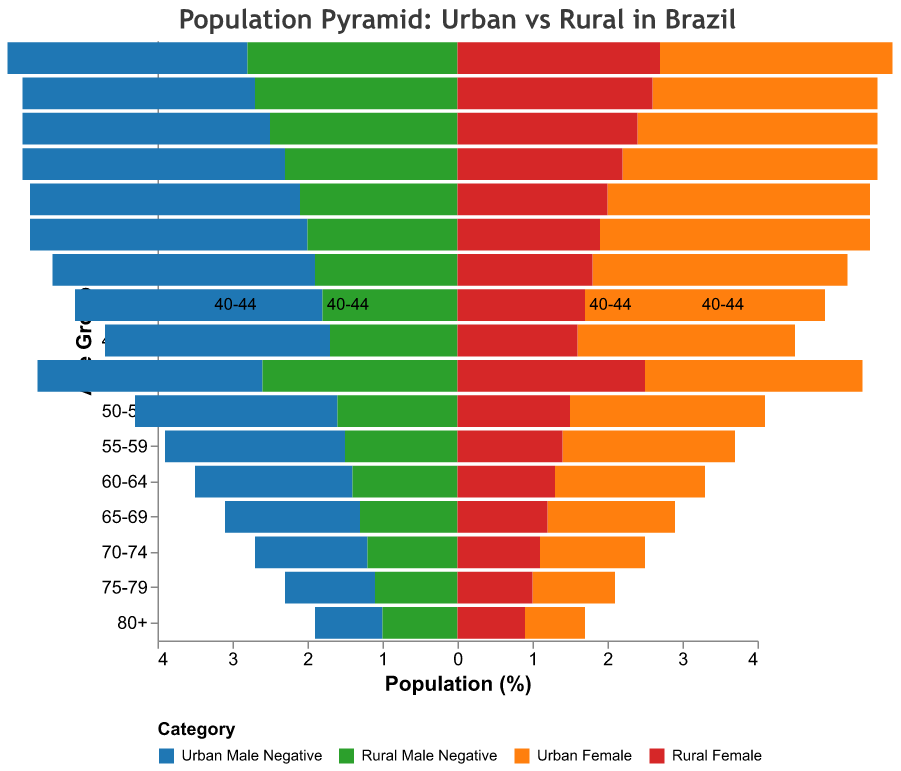What is the title of the figure? The title is usually displayed at the top of the figure. In this case, the title is "Population Pyramid: Urban vs Rural in Brazil".
Answer: Population Pyramid: Urban vs Rural in Brazil Which age group has the highest percentage of urban males? To find the age group with the highest percentage of urban males, look for the category "Urban Male" and identify the age group with the largest bar. The largest value in the "Urban Male" category is 3.7 for the age group "30-34".
Answer: 30-34 In the 80+ age group, which gender has a higher percentage in rural areas? For the age group "80+", compare the bars for "Rural Male" and "Rural Female". "Rural Male" has a value of 1.0, and "Rural Female" has a value of 0.9.
Answer: Rural Male How does the percentage of urban females in the age group 25-29 compare to that of rural females in the same age group? Identify the bars for the age group "25-29" for both "Urban Female" and "Rural Female". "Urban Female" is 3.5, and "Rural Female" is 2.0.
Answer: Urban Female has a higher percentage than Rural Female What is the difference in percentage between urban males and rural males in the age group 20-24? For the age group "20-24", identify "Urban Male" and "Rural Male" percentages. "Urban Male" is 3.5, and "Rural Male" is 2.3. Calculate the difference: 3.5 - 2.3 = 1.2.
Answer: 1.2 Which age group has approximately equal percentages of urban and rural populations for both males and females? Look for age groups where the bars for "Urban Male", "Urban Female", "Rural Male", and "Rural Female" are nearly the same. In the age group "75-79", "Urban Male" is 1.2, "Urban Female" is 1.1, "Rural Male" is 1.1, and "Rural Female" is 1.0.
Answer: 75-79 What percentage of the population in the age group 55-59 is rural females? Identify the bar for "Rural Female" in the age group "55-59". The value is 1.4.
Answer: 1.4 Is the population of urban males or urban females higher in the age group 40-44? Compare the bars for "Urban Male" and "Urban Female" in the age group "40-44". "Urban Male" is 3.3, and "Urban Female" is 3.2.
Answer: Urban Males 